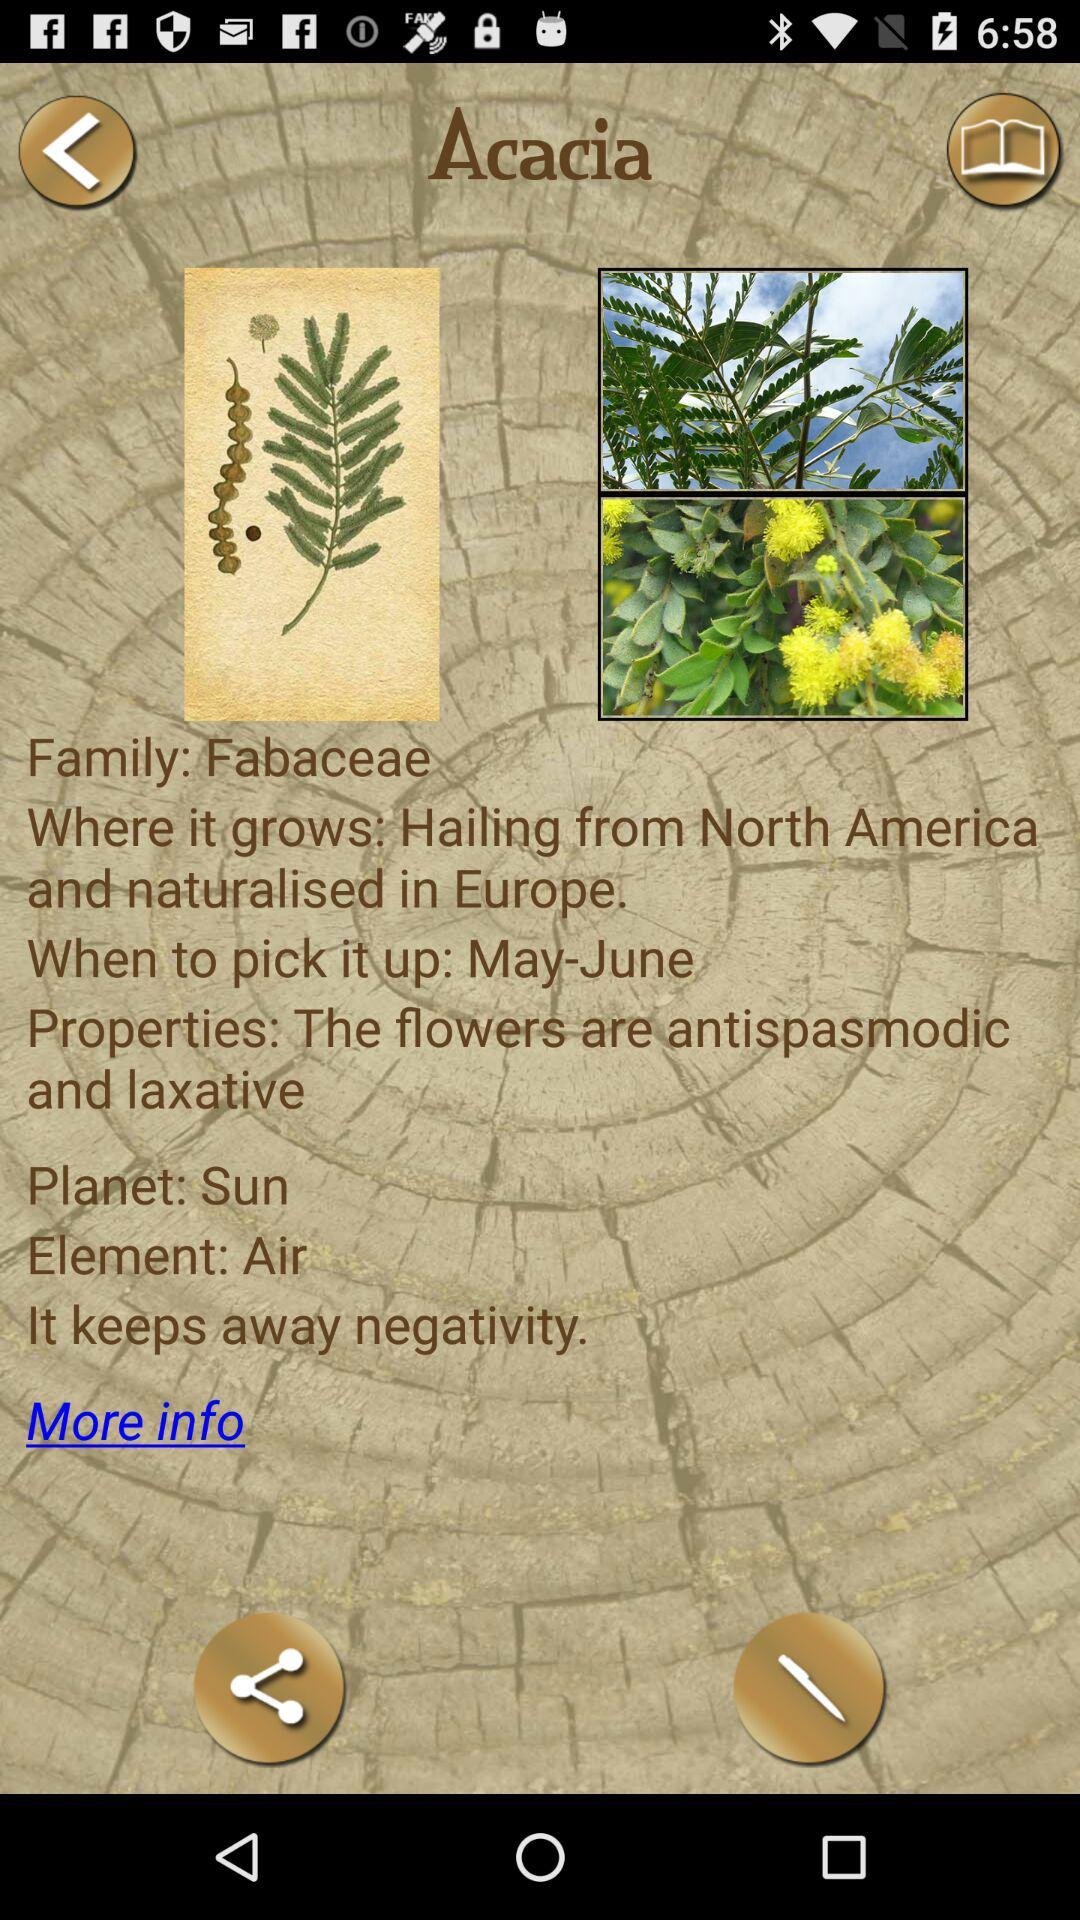Acacia belongs to which family of plant kingdom? Acacia belongs to the Fabaceae family of plants. 